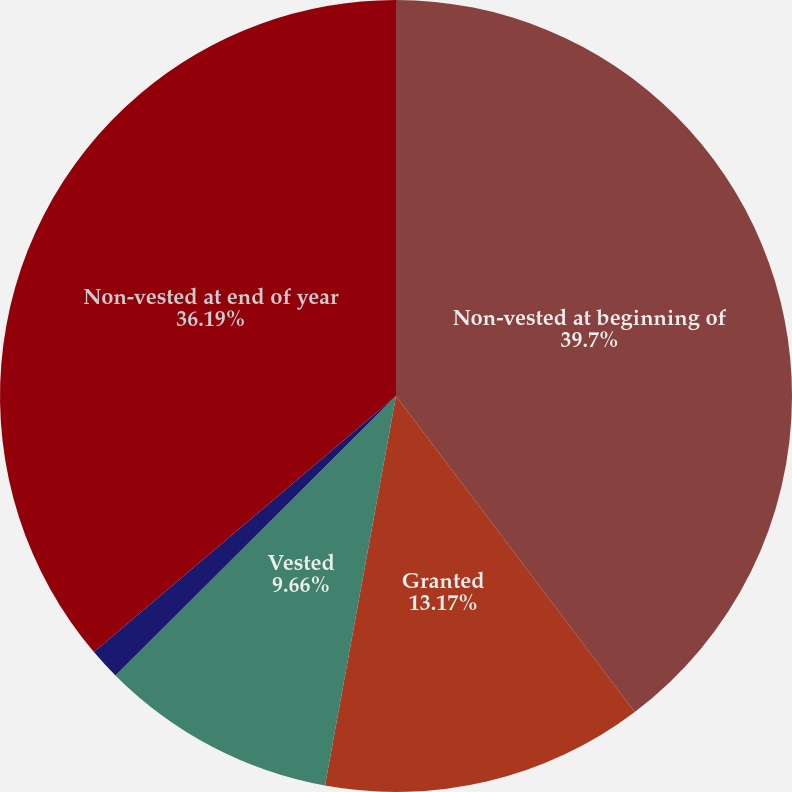<chart> <loc_0><loc_0><loc_500><loc_500><pie_chart><fcel>Non-vested at beginning of<fcel>Granted<fcel>Vested<fcel>Forfeited<fcel>Non-vested at end of year<nl><fcel>39.7%<fcel>13.17%<fcel>9.66%<fcel>1.28%<fcel>36.19%<nl></chart> 